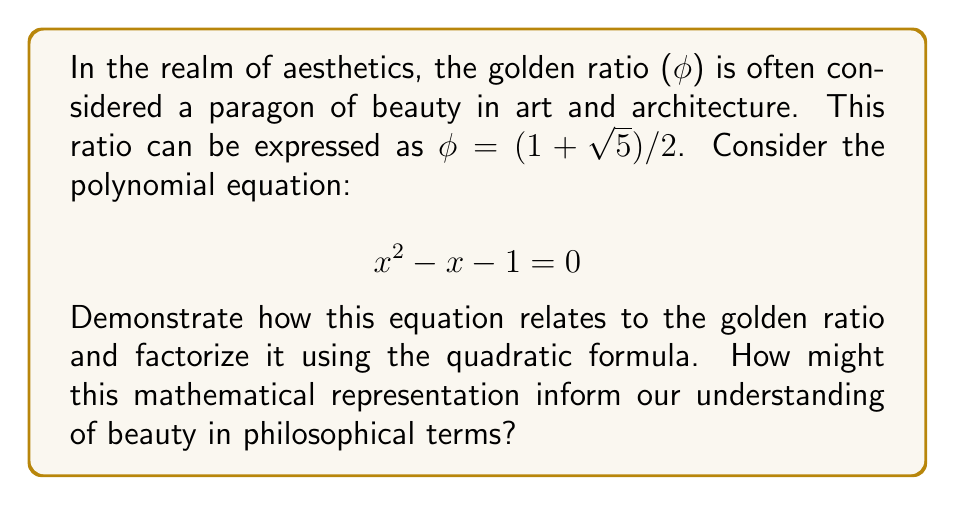Help me with this question. To approach this problem, let's break it down into steps:

1) First, we recognize that the given equation $x^2 - x - 1 = 0$ is a quadratic equation in the standard form $ax^2 + bx + c = 0$, where $a=1$, $b=-1$, and $c=-1$.

2) We can solve this equation using the quadratic formula:

   $$ x = \frac{-b \pm \sqrt{b^2 - 4ac}}{2a} $$

3) Substituting our values:

   $$ x = \frac{-(-1) \pm \sqrt{(-1)^2 - 4(1)(-1)}}{2(1)} = \frac{1 \pm \sqrt{1 + 4}}{2} = \frac{1 \pm \sqrt{5}}{2} $$

4) This gives us two solutions:

   $$ x_1 = \frac{1 + \sqrt{5}}{2} \quad \text{and} \quad x_2 = \frac{1 - \sqrt{5}}{2} $$

5) We recognize $x_1$ as the definition of the golden ratio φ.

6) To factorize the polynomial, we can use the fact that for a quadratic equation $ax^2 + bx + c = 0$ with roots $r$ and $s$, the factored form is $a(x-r)(x-s) = 0$.

7) Therefore, our factored polynomial is:

   $$ (x - \frac{1 + \sqrt{5}}{2})(x - \frac{1 - \sqrt{5}}{2}) = 0 $$

From a philosophical perspective, this mathematical representation of the golden ratio could inform our understanding of beauty in several ways:

a) It demonstrates how a simple quadratic equation can generate a ratio that's perceived as aesthetically pleasing, suggesting a link between mathematical simplicity and beauty.

b) The irrational nature of the golden ratio (due to √5) might prompt reflections on the relationship between rationality and aesthetics.

c) The fact that this ratio appears in nature (e.g., in plant growth patterns) as well as in human-made art and architecture could lead to discussions about objective versus subjective beauty.

d) The symmetry and balance inherent in the golden ratio (as seen in its algebraic representation) might inform philosophical inquiries into the nature of harmony and proportion in aesthetics.
Answer: The factored form of the polynomial $x^2 - x - 1 = 0$ is:

$$ (x - \frac{1 + \sqrt{5}}{2})(x - \frac{1 - \sqrt{5}}{2}) = 0 $$

Where $\frac{1 + \sqrt{5}}{2}$ represents the golden ratio φ. 